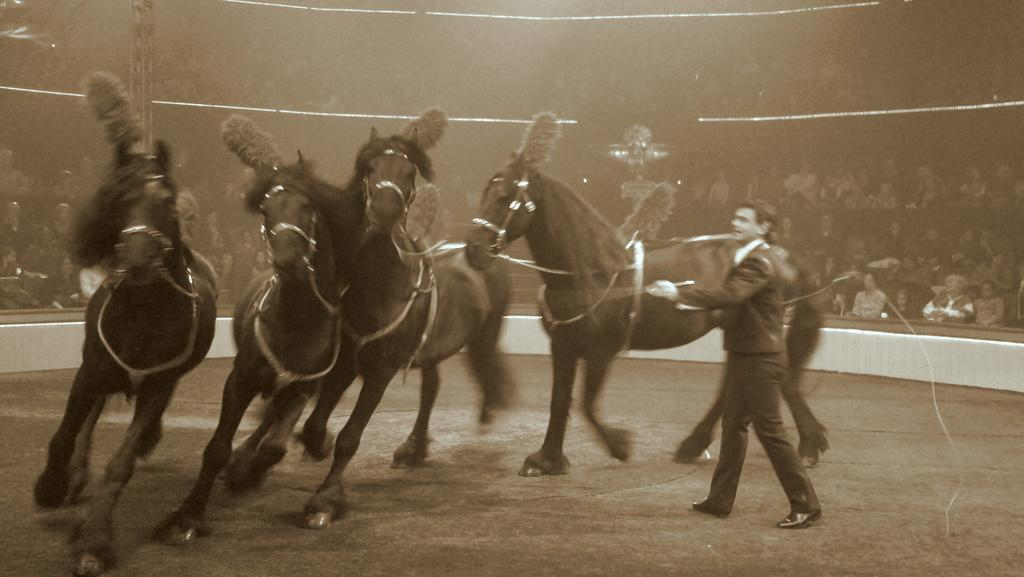What is happening with the horses in the image? The horses are running in the image. Can you describe the person in the image? There is a person standing in the image. What are the people in the image doing? There is a group of people sitting in the image. What can be seen on the left side of the image? There is a pole on the left side of the image. How does the thread begin to grow in the image? There is no thread present in the image, so it cannot begin to grow. 